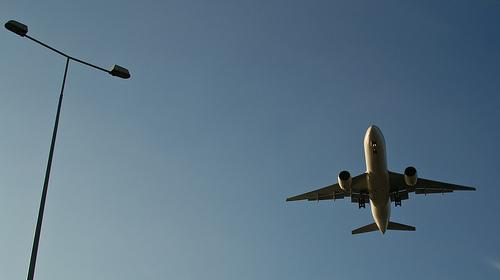Count the number of airplane engines visible in the image and provide a brief description of them. Two engines are visible on the airplane, both described as "jet engine on passenger jet" and "twin engines on plane" with specific locations and sizes provided for left and right engine. Offer a brief account of the conditions revealed in the given image, particularly with regards to the sky. The sky in the image is clear and blue, with no clouds visible, providing a perfect backdrop for a plane to fly through. What is the main object in the image and what action is it performing? The main object in the image is a plane, and it is taking off or preparing for landing. What elements in the image indicate that the airplane is either taking off or preparing for landing? The airplane's lowering landing gear and the overall positioning of the plane in the sky suggest that it is either taking off or preparing for landing. How many different objects related to an airplane can you recognize in the given image? There are at least 18 different objects related to an airplane in the image, including wings, engines, tail, landing gear, flight control surfaces, fuselage, wingtips, and flight deck. Examine the interactions between various objects in the image, and provide an insight on how they work together. The airplane's wings, engines, tail, and landing gear work together to facilitate flight, with the engines providing thrust while the wings, tail, and flight control surfaces, like elevators and flaps, help in lift, control, and stability. Provide a detailed assessment of the image quality and any features that stand out as exceptional. The image has a high-quality representation of an airplane in flight and its surroundings. The clarity and details of the airplane's various parts, the cloudless blue sky, and the outdoor light fixture, are well-defined and viewable. Identify one object in the image that is not related to the airplane and provide a brief description of it. There is a light fixture hanging from a pole in the image, which is a part of outdoor lighting with support structure and lights on the pole. What are the emotions or feelings associated with this image? Please provide at least 2 different sentiments. The image conveys a sense of wonder and excitement, as we watch an airplane taking off, soaring through the blue, cloudless sky. Provide a detailed description of the airplane's wing, including any particular features or elements it contains. The airplane wing features include its large size providing lift, the presence of two engines for propulsion, and the use of flaps and ailerons for controlling and stabilizing the airplane during flight. Determine the color of the airplane in the image. silver Is the plane in the image a red plane landing in a cloudy sky? The plane in the image is silver, not red, and the sky is clear and blue, not cloudy. Identify an action the plane is performing in the image. preparing for landing What type of object supports the outdoor lights in the image? a tall metal pole Is the light fixture positioned at the bottom-right corner of the image? The light fixture is positioned at the top-left corner of the image, with X:0 and Y:11 coordinates. Can you see three engines on the airplane in the image? No, it's not mentioned in the image. What type of object is found atop a tall metal pole in the image? two lights What is the primary color of the sky in the image? blue Write an old-fashioned styled description of the image. Aeroplane soars gracefully through a bright azure sky, whilst below, electric lamps stand sentinel atop their tall metal pole. Select the correct option: Is the sky in the image cloudy or cloudless? cloudless Is the tail of the plane positioned at the top-left corner of the image with X:50 and Y:50 coordinates? The tail of the plane is positioned at X:349 and Y:216, not at X:50 and Y:50. In a poetic language, describe the appearance of the airplane. A gleaming silver bird, soaring through the boundless sky with mighty twin engines and graceful wings. Describe a complex action taking place in the image. landing gear lowering on a plane How many engines does the plane have? two Which part of the airplane is the right engine closest to? the wing In an adventurous language, describe the scene of the image. A daring silver jetliner prepares for a thrilling touchdown under the vast, clear blue sky, as steadfast streetlights stand by to witness the spectacle. What is one possible future event for the plane in the image? landing Locate the position of the plane's nose. front of the plane, near the top Identify the airplane's control surface in the image. elevator flight control surface State the position of the sky in the image. background Choose the correct statement about the lights in the image: A. They are indoor lights. B. They are outdoor lights. B. They are outdoor lights. Can you see an animal sitting on the wing of the airplane? The image information does not mention any animals on the airplane's wing, so it would be misleading to ask about it. Where is the plane's main fuselage located in the image? near the center 